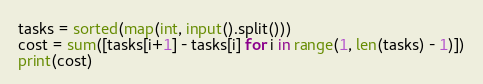Convert code to text. <code><loc_0><loc_0><loc_500><loc_500><_Python_>tasks = sorted(map(int, input().split()))
cost = sum([tasks[i+1] - tasks[i] for i in range(1, len(tasks) - 1)])
print(cost)
</code> 